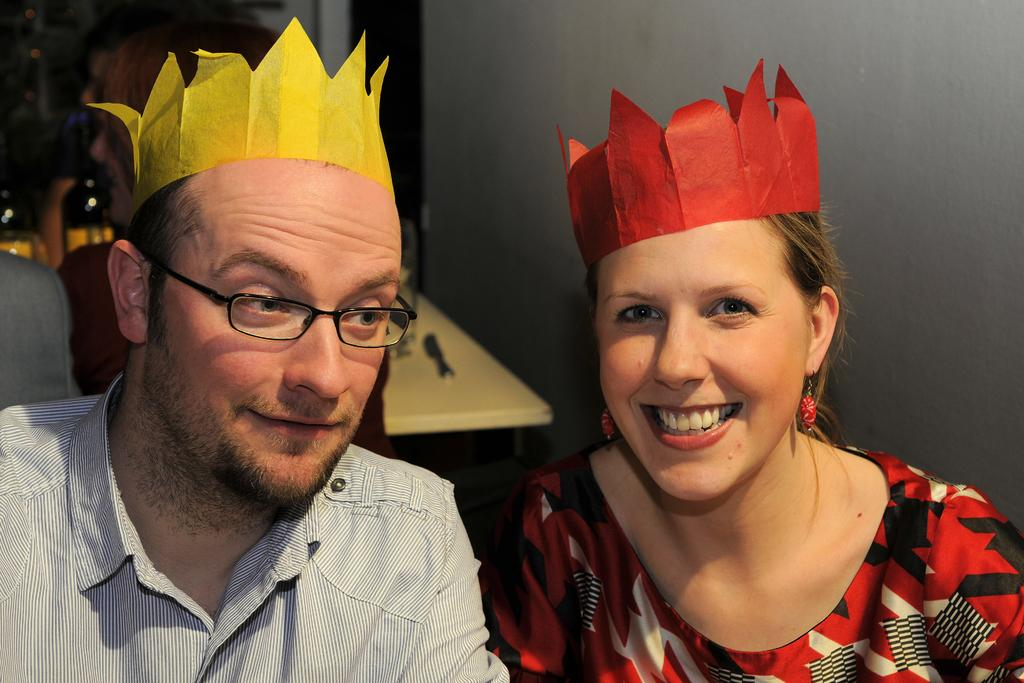What are the people in the image doing? The people in the image are sitting on chairs. Can you describe any unique features of the people in the image? Two people are wearing paper crowns on their heads. What can be seen on the table in the image? There are objects placed on a table in the image. What type of music can be heard coming from the cat in the image? There is no cat present in the image, so it's not possible to determine what, if any, music might be heard. 